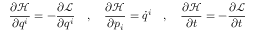<formula> <loc_0><loc_0><loc_500><loc_500>{ \frac { \partial { \mathcal { H } } } { \partial q ^ { i } } } = - { \frac { \partial { \mathcal { L } } } { \partial q ^ { i } } } \quad , \quad \frac { \partial { \mathcal { H } } } { \partial p _ { i } } = { \dot { q } } ^ { i } \quad , \quad \frac { \partial { \mathcal { H } } } { \partial t } = - { \frac { \partial { \mathcal { L } } } { \partial t } }</formula> 